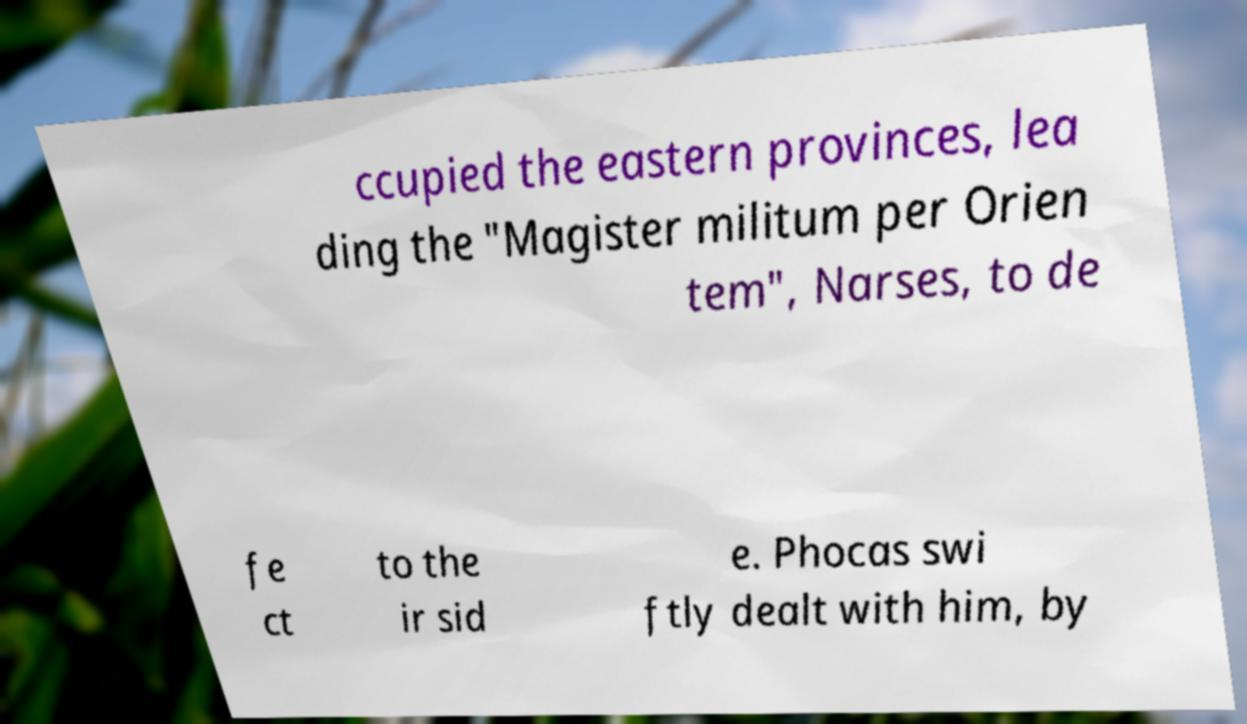Could you assist in decoding the text presented in this image and type it out clearly? ccupied the eastern provinces, lea ding the "Magister militum per Orien tem", Narses, to de fe ct to the ir sid e. Phocas swi ftly dealt with him, by 